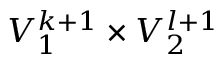Convert formula to latex. <formula><loc_0><loc_0><loc_500><loc_500>V _ { 1 } ^ { k + 1 } \times V _ { 2 } ^ { l + 1 }</formula> 